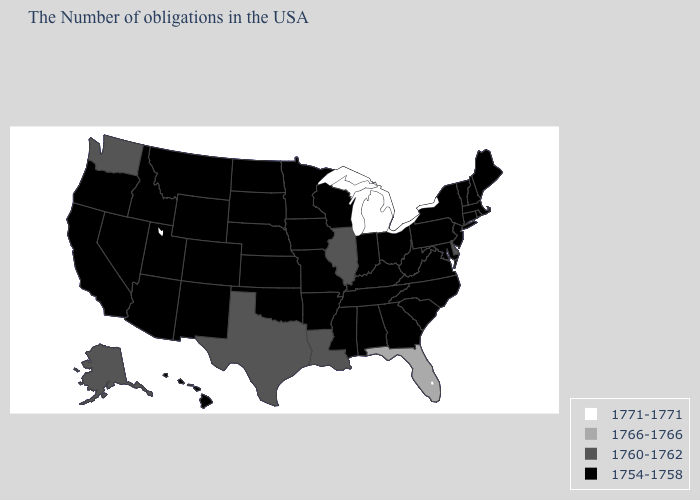Which states hav the highest value in the Northeast?
Write a very short answer. Maine, Massachusetts, Rhode Island, New Hampshire, Vermont, Connecticut, New York, New Jersey, Pennsylvania. Does Washington have the same value as New York?
Be succinct. No. What is the value of Missouri?
Write a very short answer. 1754-1758. What is the value of Mississippi?
Quick response, please. 1754-1758. What is the highest value in the USA?
Be succinct. 1771-1771. What is the highest value in the Northeast ?
Quick response, please. 1754-1758. Does Washington have the highest value in the West?
Write a very short answer. Yes. Name the states that have a value in the range 1771-1771?
Short answer required. Michigan. What is the value of Oklahoma?
Be succinct. 1754-1758. Does New Jersey have a lower value than Florida?
Answer briefly. Yes. What is the value of Washington?
Be succinct. 1760-1762. Among the states that border Wyoming , which have the highest value?
Concise answer only. Nebraska, South Dakota, Colorado, Utah, Montana, Idaho. Is the legend a continuous bar?
Answer briefly. No. Does Washington have the highest value in the West?
Short answer required. Yes. What is the value of Virginia?
Be succinct. 1754-1758. 